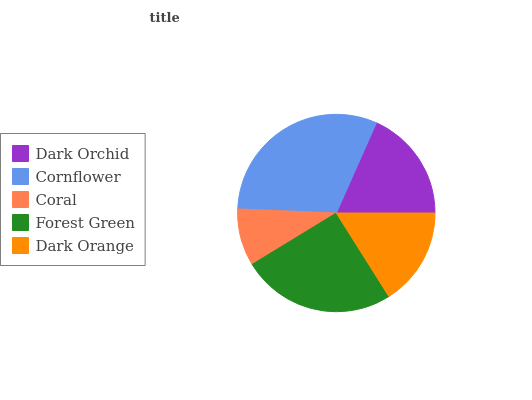Is Coral the minimum?
Answer yes or no. Yes. Is Cornflower the maximum?
Answer yes or no. Yes. Is Cornflower the minimum?
Answer yes or no. No. Is Coral the maximum?
Answer yes or no. No. Is Cornflower greater than Coral?
Answer yes or no. Yes. Is Coral less than Cornflower?
Answer yes or no. Yes. Is Coral greater than Cornflower?
Answer yes or no. No. Is Cornflower less than Coral?
Answer yes or no. No. Is Dark Orchid the high median?
Answer yes or no. Yes. Is Dark Orchid the low median?
Answer yes or no. Yes. Is Forest Green the high median?
Answer yes or no. No. Is Cornflower the low median?
Answer yes or no. No. 